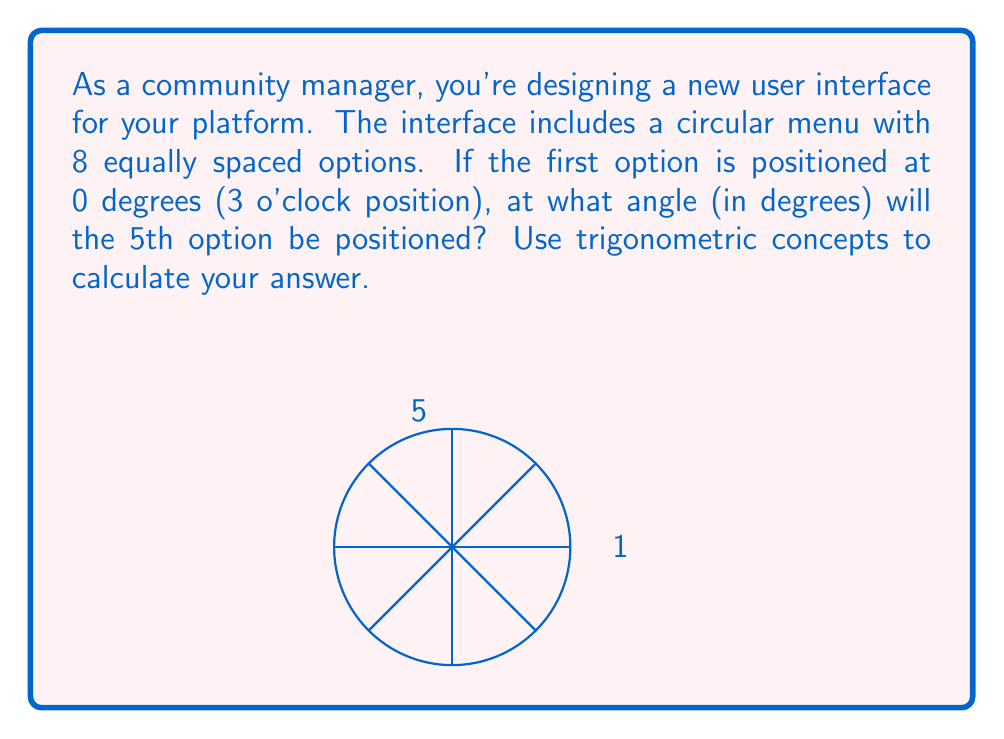What is the answer to this math problem? To solve this problem, we can follow these steps:

1) First, we need to understand that a full circle has 360 degrees.

2) Since there are 8 equally spaced options, we can calculate the angle between each option:

   $$\text{Angle between options} = \frac{360^\circ}{8} = 45^\circ$$

3) The 5th option is 4 positions away from the 1st option (counting the spaces between them).

4) Therefore, we can calculate the angle of the 5th option:

   $$\text{Angle of 5th option} = 4 \times 45^\circ = 180^\circ$$

5) We can verify this using trigonometry. The coordinates of the 5th option on a unit circle would be:

   $$x = \cos(180^\circ) = -1$$
   $$y = \sin(180^\circ) = 0$$

   This indeed corresponds to the 9 o'clock position (left side of the circle), which is where the 5th option should be.
Answer: $180^\circ$ 